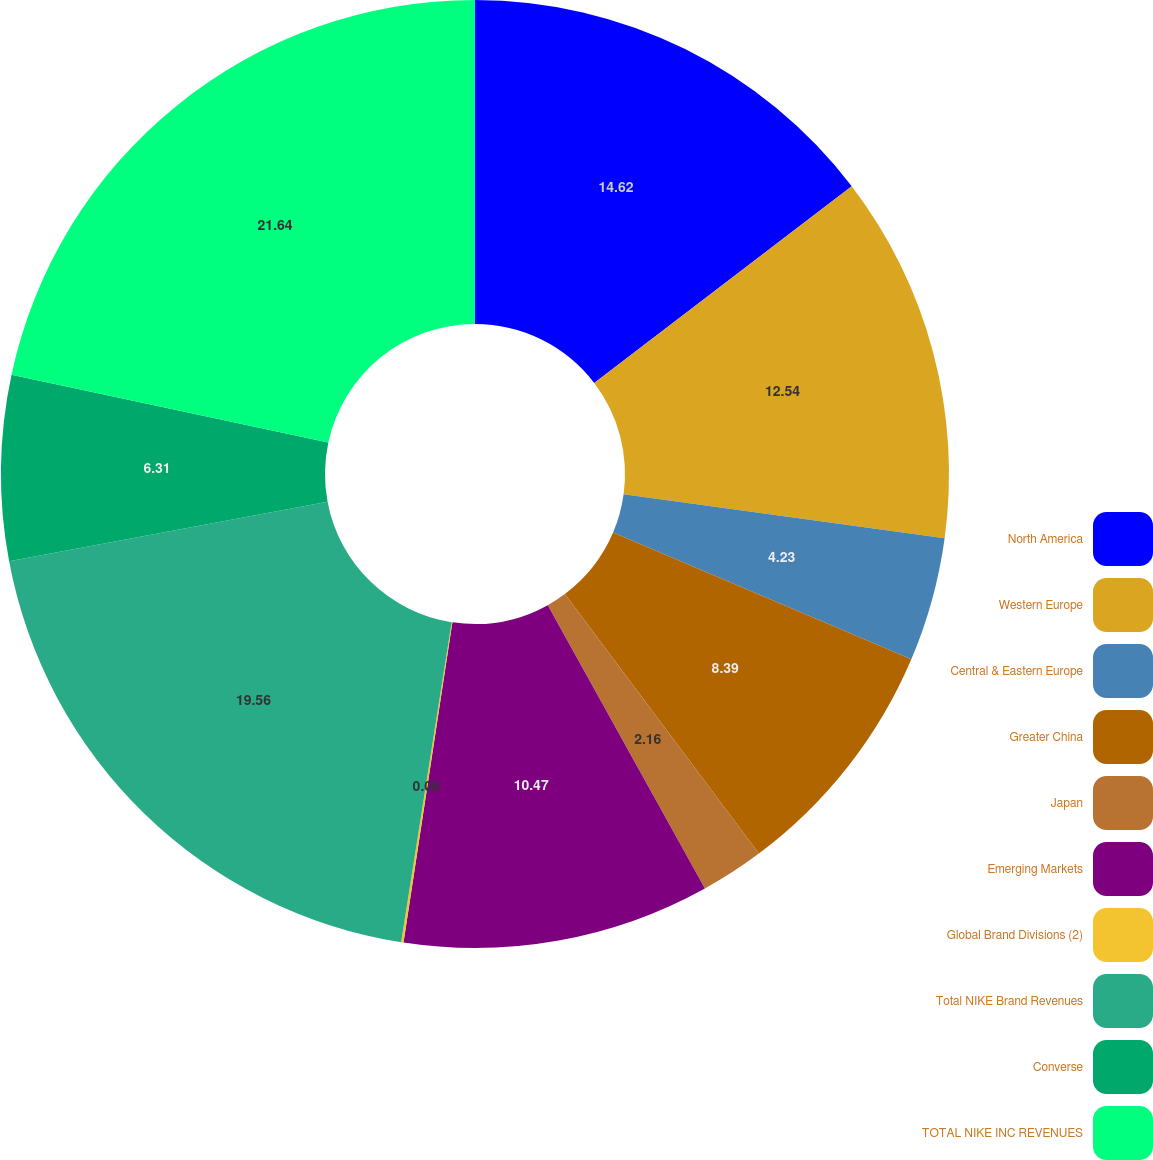Convert chart to OTSL. <chart><loc_0><loc_0><loc_500><loc_500><pie_chart><fcel>North America<fcel>Western Europe<fcel>Central & Eastern Europe<fcel>Greater China<fcel>Japan<fcel>Emerging Markets<fcel>Global Brand Divisions (2)<fcel>Total NIKE Brand Revenues<fcel>Converse<fcel>TOTAL NIKE INC REVENUES<nl><fcel>14.62%<fcel>12.54%<fcel>4.23%<fcel>8.39%<fcel>2.16%<fcel>10.47%<fcel>0.08%<fcel>19.56%<fcel>6.31%<fcel>21.64%<nl></chart> 